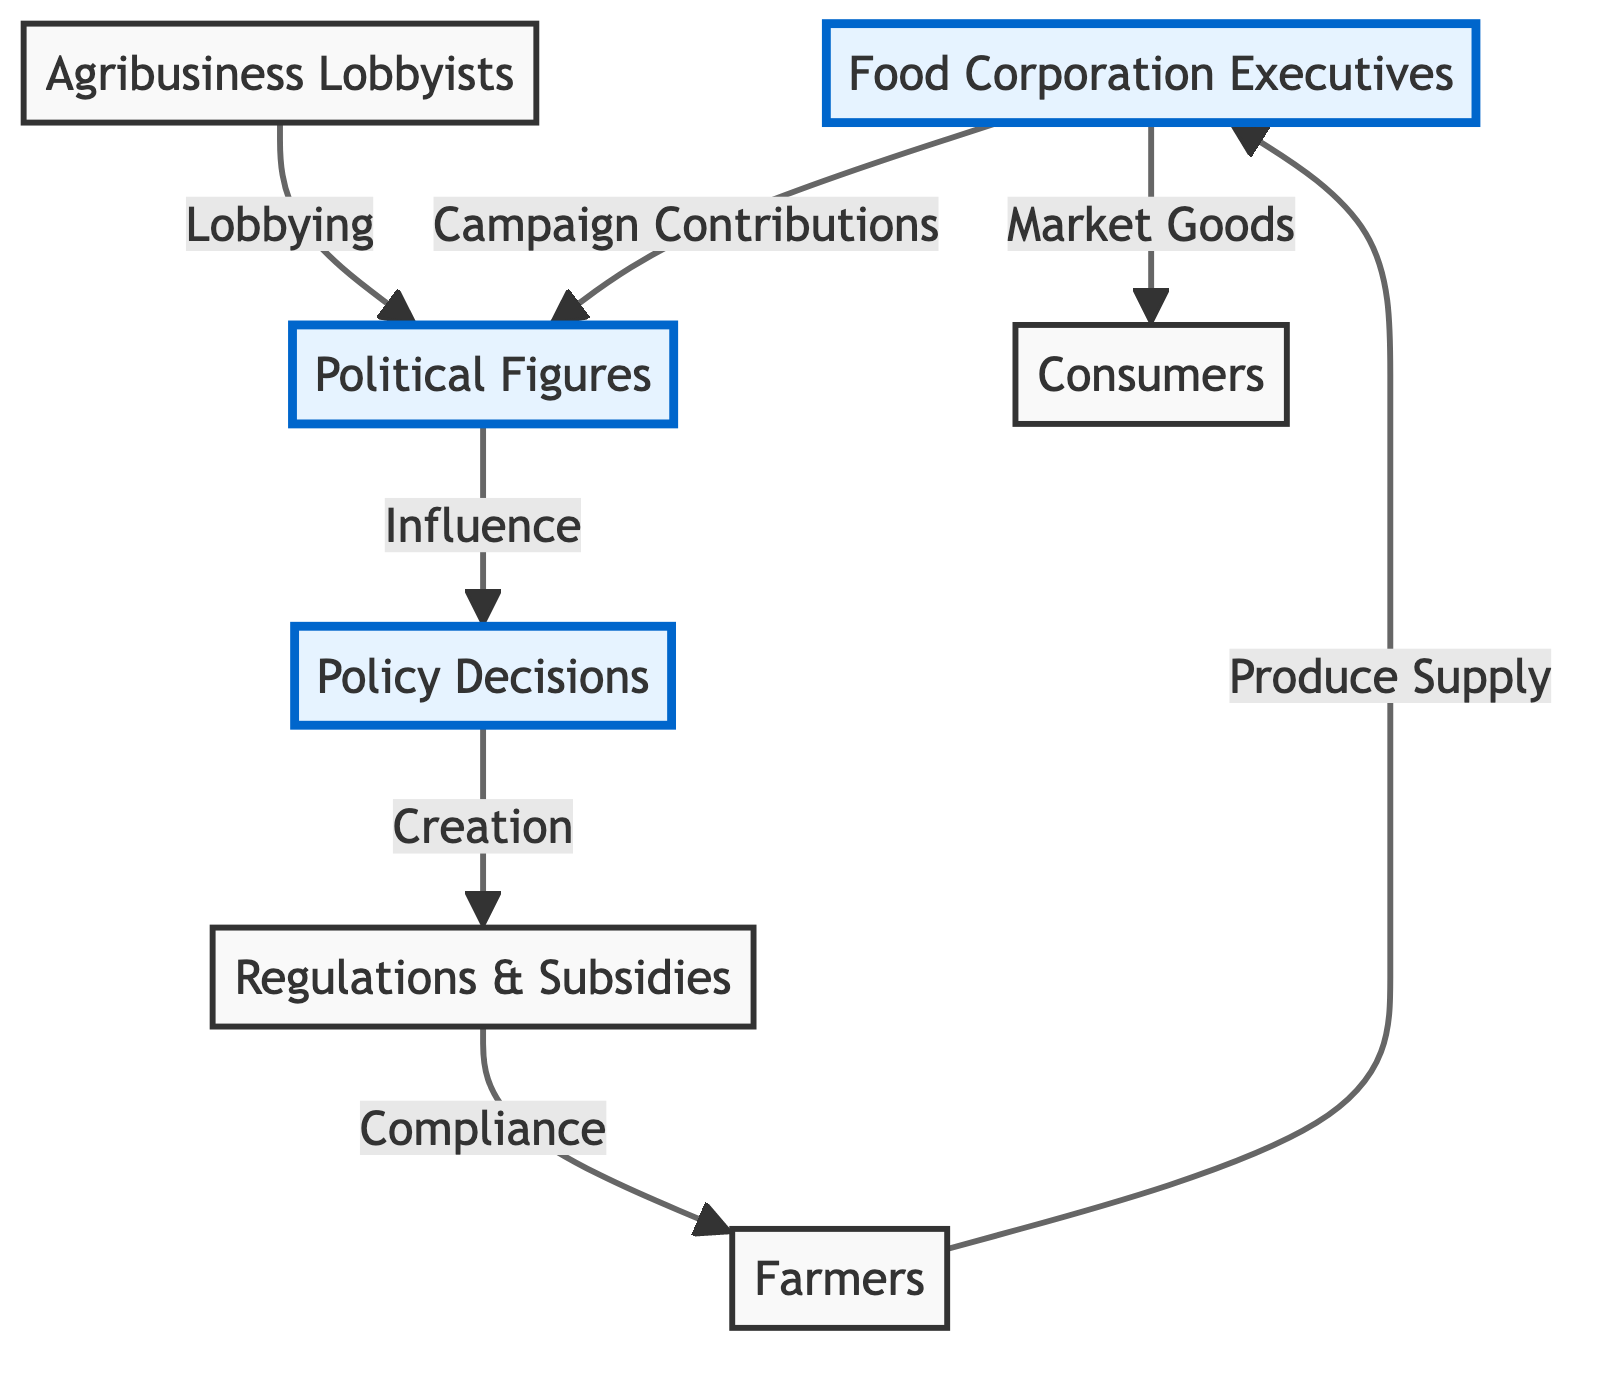What are the main actors in the food chain? The food chain involves six main actors: Food Corporation Executives, Political Figures, Agribusiness Lobbyists, Policy Decisions, Farmers, and Consumers. These nodes represent key players in the agricultural sector.
Answer: Food Corporation Executives, Political Figures, Agribusiness Lobbyists, Policy Decisions, Farmers, Consumers How are Food Corporation Executives connected to Political Figures? Food Corporation Executives connect to Political Figures through "Campaign Contributions," indicating that executives influence politicians' decisions financially.
Answer: Campaign Contributions What influences Policy Decisions? Policy Decisions are influenced by Political Figures, which highlights the role that politicians have in shaping agricultural policies based on their relationships and influences.
Answer: Political Figures How many connections lead to Consumers? There is one connection leading to Consumers, which is from Food Corporation Executives, showing that they market goods for consumer consumption.
Answer: One What is the relationship between Policy Decisions and Regulations & Subsidies? The relationship is that Policy Decisions lead to the "Creation" of Regulations & Subsidies, indicating that policies have a direct impact on the establishment of rules and support mechanisms in agriculture.
Answer: Creation What do Farmers do in the food chain? Farmers "Produce Supply" to Food Corporation Executives, which indicates their role in supplying goods that are necessary for the food market.
Answer: Produce Supply What is one way Agribusiness Lobbyists influence Political Figures? Agribusiness Lobbyists influence Political Figures through "Lobbying," which refers to their efforts to persuade politicians to adopt favorable policies for agribusiness interests.
Answer: Lobbying What is the nature of compliance concerning Regulations & Subsidies? Farmers must comply with Regulations & Subsidies, demonstrating that these regulations impose requirements that farmers need to follow in their practices.
Answer: Compliance What flows from Executives to Consumers? The flow is "Market Goods," which represents the process through which Food Corporation Executives provide food products to Consumers after obtaining them from Farmers.
Answer: Market Goods 